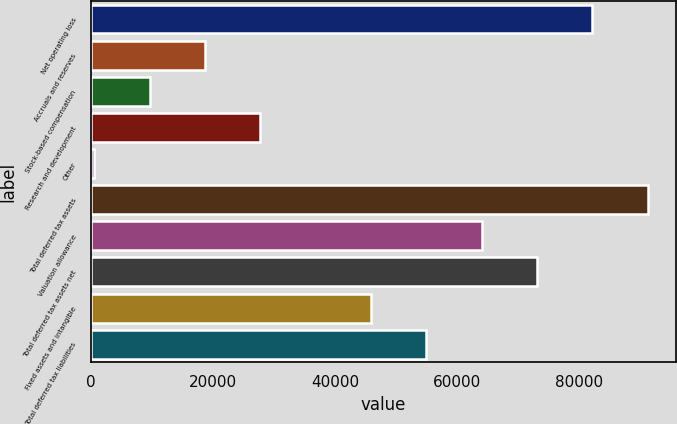<chart> <loc_0><loc_0><loc_500><loc_500><bar_chart><fcel>Net operating loss<fcel>Accruals and reserves<fcel>Stock-based compensation<fcel>Research and development<fcel>Other<fcel>Total deferred tax assets<fcel>Valuation allowance<fcel>Total deferred tax assets net<fcel>Fixed assets and intangible<fcel>Total deferred tax liabilities<nl><fcel>82111.3<fcel>18721.4<fcel>9665.7<fcel>27777.1<fcel>610<fcel>91167<fcel>63999.9<fcel>73055.6<fcel>45888.5<fcel>54944.2<nl></chart> 